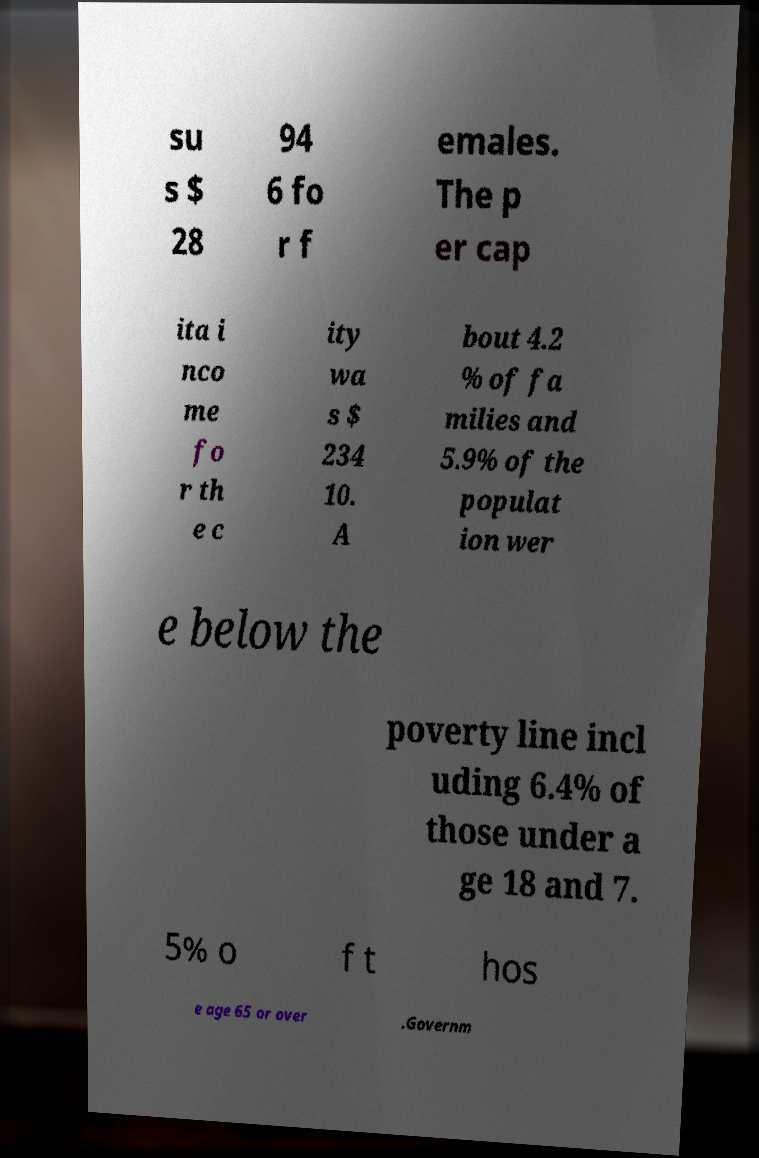I need the written content from this picture converted into text. Can you do that? su s $ 28 94 6 fo r f emales. The p er cap ita i nco me fo r th e c ity wa s $ 234 10. A bout 4.2 % of fa milies and 5.9% of the populat ion wer e below the poverty line incl uding 6.4% of those under a ge 18 and 7. 5% o f t hos e age 65 or over .Governm 